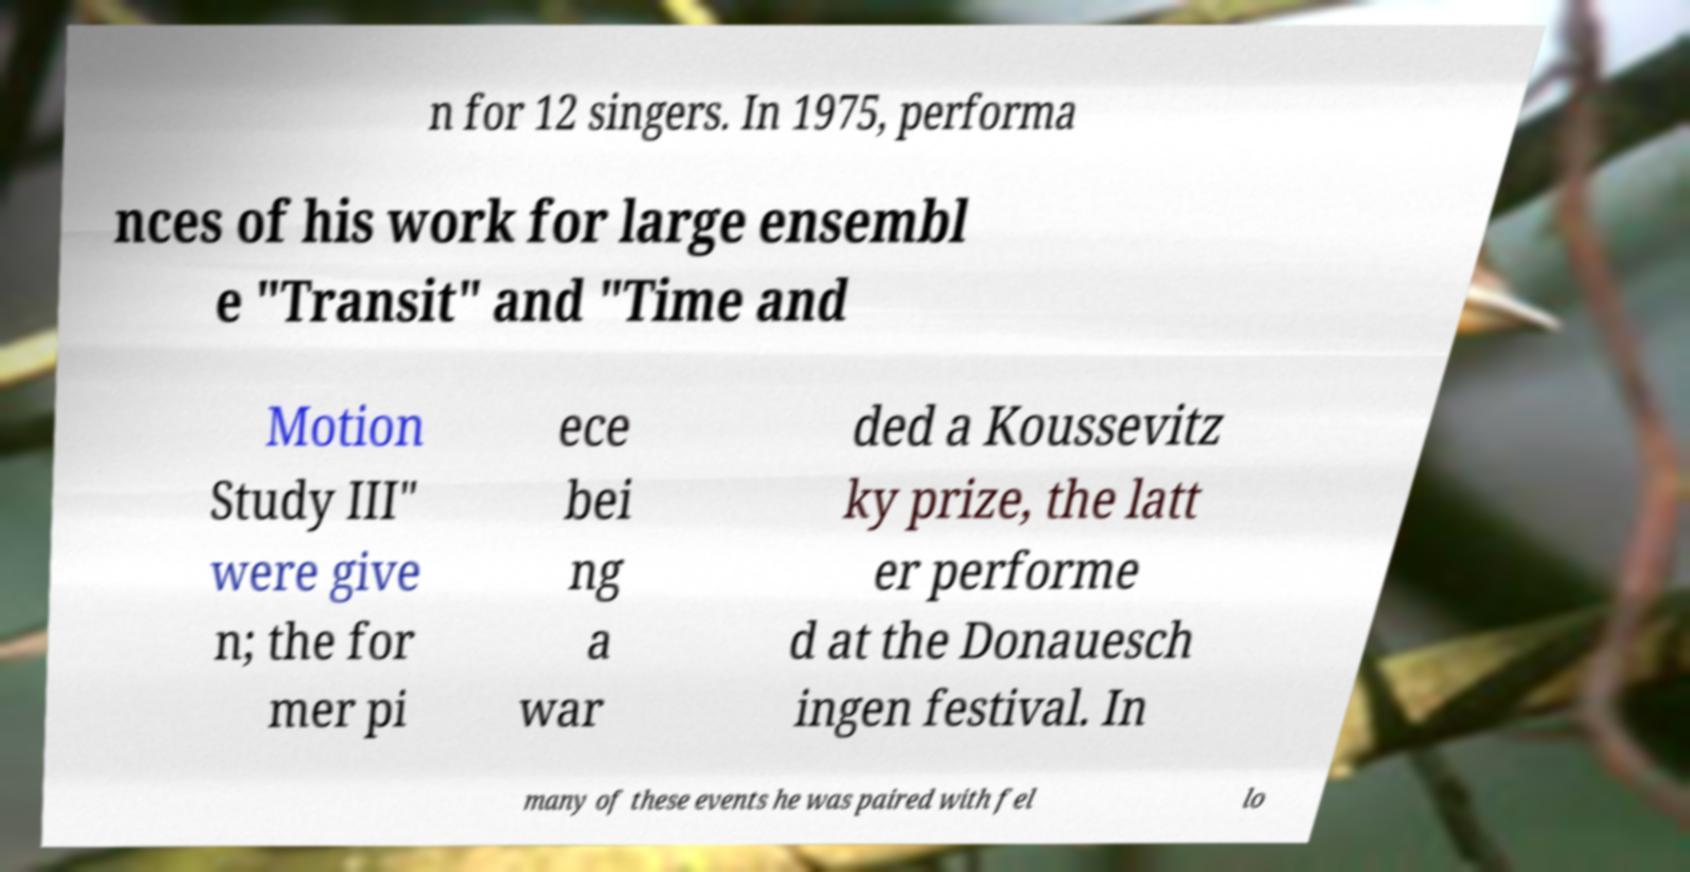Could you assist in decoding the text presented in this image and type it out clearly? n for 12 singers. In 1975, performa nces of his work for large ensembl e "Transit" and "Time and Motion Study III" were give n; the for mer pi ece bei ng a war ded a Koussevitz ky prize, the latt er performe d at the Donauesch ingen festival. In many of these events he was paired with fel lo 